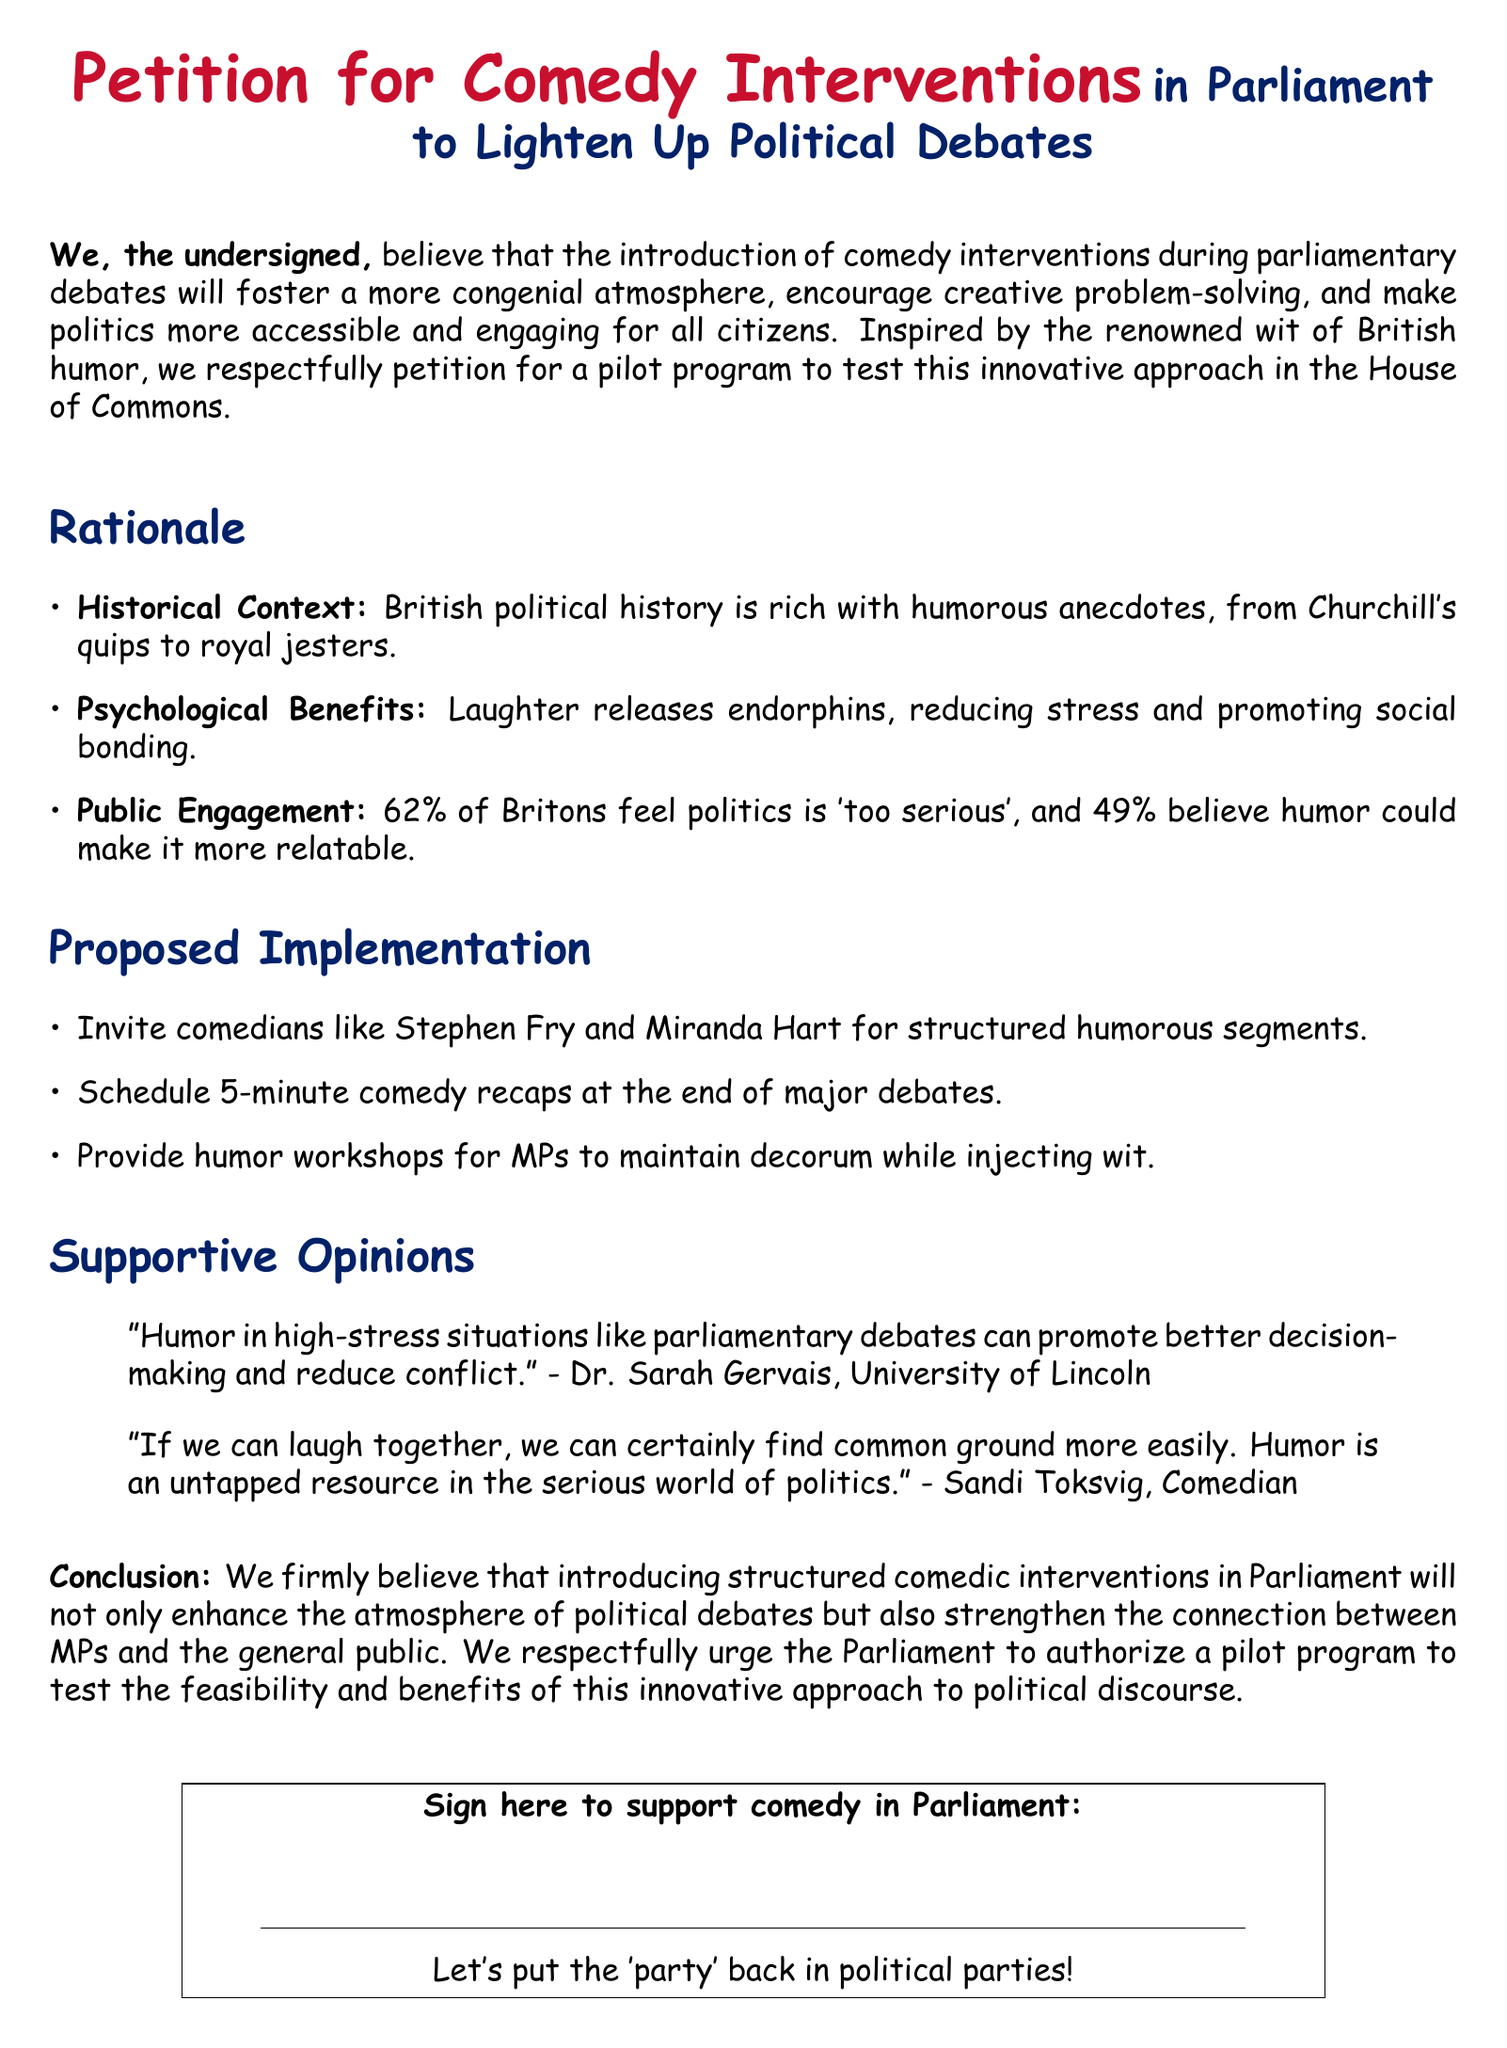What is the title of the petition? The title is prominently displayed at the top of the document, indicating the subject matter of the petition clearly.
Answer: Petition for Comedy Interventions What percentage of Britons feel politics is 'too serious'? This percentage is mentioned in the "Public Engagement" section, reflecting public perception.
Answer: 62% Who are two comedians mentioned as potential candidates for the pilot program? Their names are listed as examples of comedians who could be invited, showcasing the humor aspect of the proposal.
Answer: Stephen Fry and Miranda Hart What is one psychological benefit of laughter mentioned in the document? This benefit is outlined in the "Psychological Benefits" section, emphasizing the positive impact of humor.
Answer: Reducing stress Who is quoted regarding humor in high-stress situations? The quote provides support for the rationale behind the petition and adds credibility from an expert perspective.
Answer: Dr. Sarah Gervais What phrase is used to encourage signing the petition? This phrase serves as a humorous call to action, aligning with the theme of the petition.
Answer: Let's put the 'party' back in political parties! What is the proposed duration for comedy recaps at the end of major debates? The specific duration is provided in the "Proposed Implementation" section, outlining a structured approach.
Answer: 5 minutes What is the overall goal of the petition? The goal summarizes the intent behind the petition and what the authors hope to achieve through it.
Answer: To enhance the atmosphere of political debates 